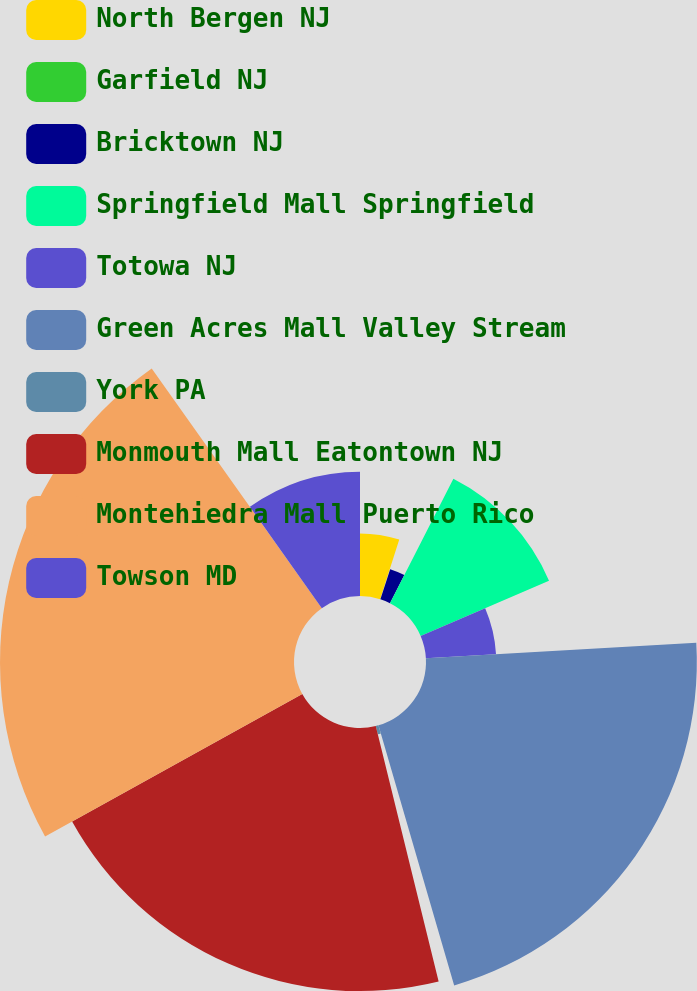<chart> <loc_0><loc_0><loc_500><loc_500><pie_chart><fcel>North Bergen NJ<fcel>Garfield NJ<fcel>Bricktown NJ<fcel>Springfield Mall Springfield<fcel>Totowa NJ<fcel>Green Acres Mall Valley Stream<fcel>York PA<fcel>Monmouth Mall Eatontown NJ<fcel>Montehiedra Mall Puerto Rico<fcel>Towson MD<nl><fcel>4.94%<fcel>0.06%<fcel>2.5%<fcel>11.04%<fcel>5.55%<fcel>21.4%<fcel>0.67%<fcel>20.79%<fcel>23.23%<fcel>9.82%<nl></chart> 